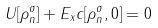Convert formula to latex. <formula><loc_0><loc_0><loc_500><loc_500>U [ \rho _ { n } ^ { \sigma } ] + E _ { x } c [ \rho _ { n } ^ { \sigma } , 0 ] = 0</formula> 